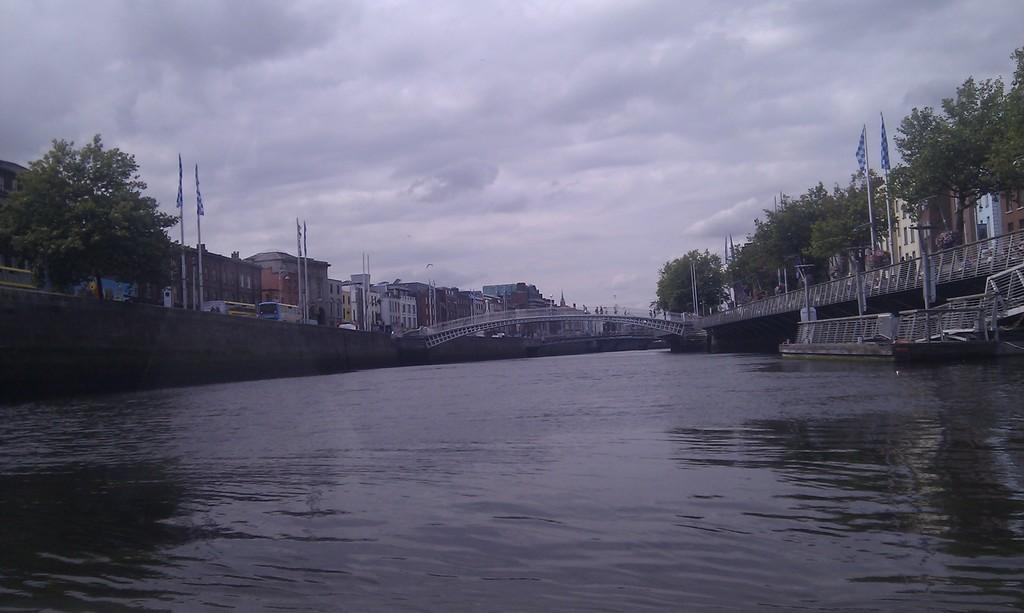What is the main feature of the image? There is water in the image. What structure can be seen crossing over the water? There is a bridge in the image. What type of vegetation is present in the image? There are trees in the image. What decorative elements are visible in the image? There are flags in the image. What type of structures are present on either side of the water? There are buildings on either side of the image. How would you describe the weather in the image? The sky in the background is cloudy. What type of baseball game is being played in the image? There is no baseball game present in the image. How does the alley affect the view of the water in the image? There is no alley present in the image. 